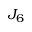Convert formula to latex. <formula><loc_0><loc_0><loc_500><loc_500>J _ { 6 }</formula> 